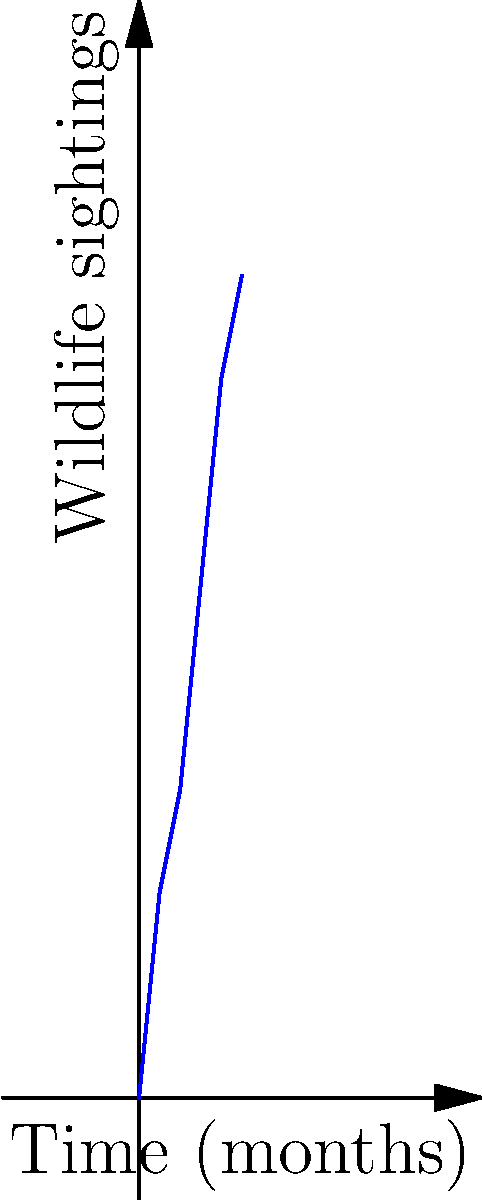Based on the trail camera data from your property adjacent to the national park, as shown in the graph, estimate the wildlife population density in your area after 6 months. Assume a linear relationship between time and wildlife sightings, and that each sighting represents approximately 5% of the total population in a 1 km² area. How many animals per km² would you expect? To solve this problem, we'll follow these steps:

1. Determine the linear relationship between time and wildlife sightings:
   - Use the slope formula: $m = \frac{y_2 - y_1}{x_2 - x_1}$
   - Choose two points: (0, 0) and (5, 40)
   - $m = \frac{40 - 0}{5 - 0} = 8$ sightings per month

2. Use the linear equation to predict sightings at 6 months:
   - $y = mx + b$, where $b = 0$ (y-intercept)
   - $y = 8 * 6 + 0 = 48$ sightings

3. Convert sightings to population estimate:
   - Each sighting represents 5% of the population
   - Total population = $\frac{48}{0.05} = 960$ animals

4. Calculate density per km²:
   - Given: 1 km² area
   - Density = $\frac{960\text{ animals}}{1\text{ km}^2} = 960\text{ animals/km}^2$
Answer: 960 animals/km² 